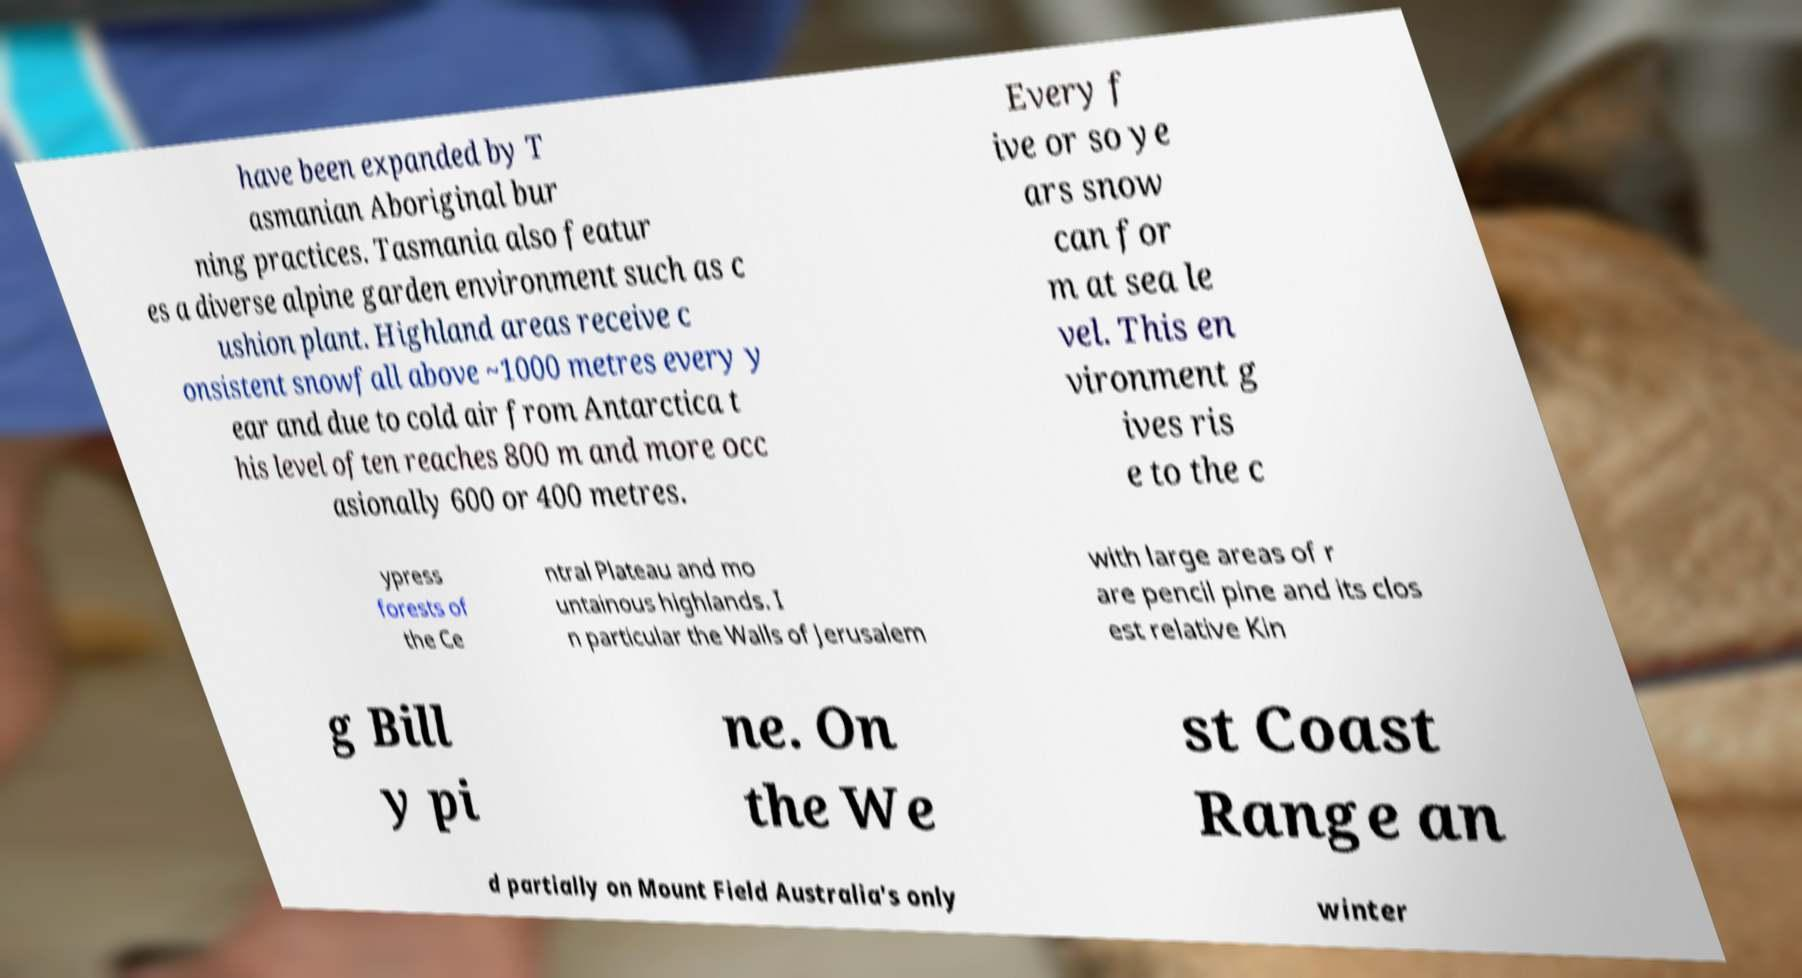Can you accurately transcribe the text from the provided image for me? have been expanded by T asmanian Aboriginal bur ning practices. Tasmania also featur es a diverse alpine garden environment such as c ushion plant. Highland areas receive c onsistent snowfall above ~1000 metres every y ear and due to cold air from Antarctica t his level often reaches 800 m and more occ asionally 600 or 400 metres. Every f ive or so ye ars snow can for m at sea le vel. This en vironment g ives ris e to the c ypress forests of the Ce ntral Plateau and mo untainous highlands. I n particular the Walls of Jerusalem with large areas of r are pencil pine and its clos est relative Kin g Bill y pi ne. On the We st Coast Range an d partially on Mount Field Australia's only winter 